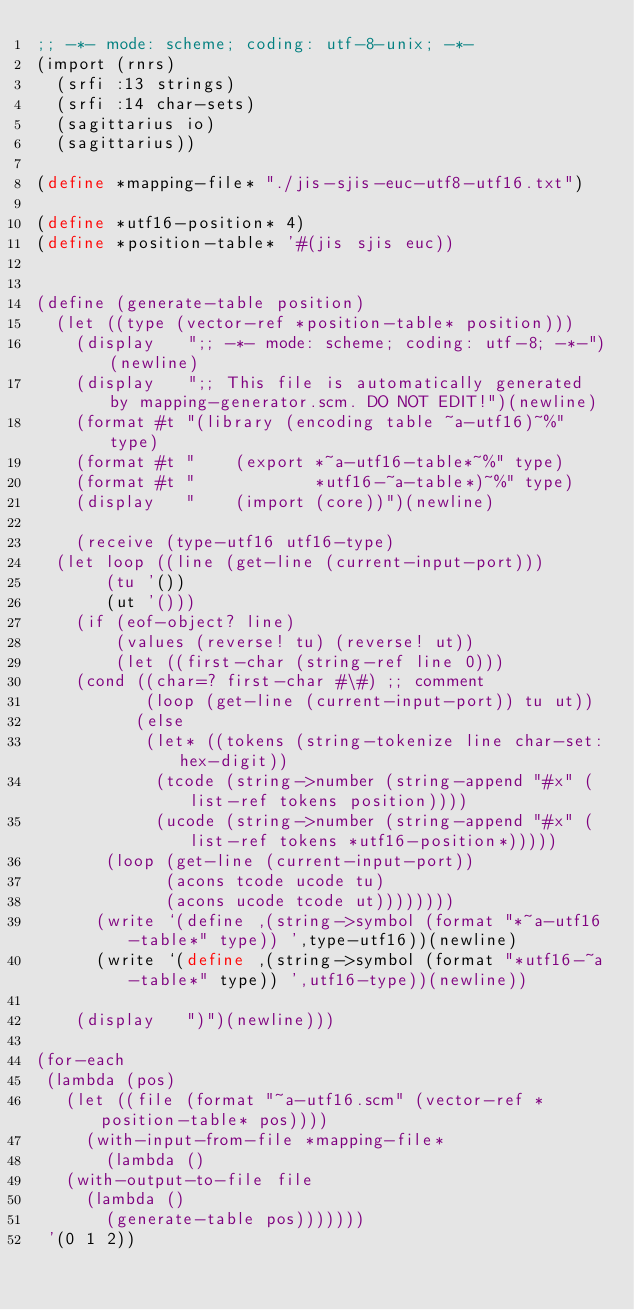Convert code to text. <code><loc_0><loc_0><loc_500><loc_500><_Scheme_>;; -*- mode: scheme; coding: utf-8-unix; -*-
(import (rnrs)
	(srfi :13 strings)
	(srfi :14 char-sets)
	(sagittarius io)
	(sagittarius))

(define *mapping-file* "./jis-sjis-euc-utf8-utf16.txt")

(define *utf16-position* 4)
(define *position-table* '#(jis sjis euc))


(define (generate-table position)
  (let ((type (vector-ref *position-table* position)))
    (display   ";; -*- mode: scheme; coding: utf-8; -*-")(newline)
    (display   ";; This file is automatically generated by mapping-generator.scm. DO NOT EDIT!")(newline)
    (format #t "(library (encoding table ~a-utf16)~%" type)
    (format #t "    (export *~a-utf16-table*~%" type)
    (format #t "            *utf16-~a-table*)~%" type)
    (display   "    (import (core))")(newline)

    (receive (type-utf16 utf16-type)
	(let loop ((line (get-line (current-input-port)))
		   (tu '())
		   (ut '()))
	  (if (eof-object? line)
	      (values (reverse! tu) (reverse! ut))
	      (let ((first-char (string-ref line 0)))
		(cond ((char=? first-char #\#) ;; comment
		       (loop (get-line (current-input-port)) tu ut))
		      (else
		       (let* ((tokens (string-tokenize line char-set:hex-digit))
			      (tcode (string->number (string-append "#x" (list-ref tokens position))))
			      (ucode (string->number (string-append "#x" (list-ref tokens *utf16-position*)))))
			 (loop (get-line (current-input-port))
			       (acons tcode ucode tu)
			       (acons ucode tcode ut))))))))
      (write `(define ,(string->symbol (format "*~a-utf16-table*" type)) ',type-utf16))(newline)
      (write `(define ,(string->symbol (format "*utf16-~a-table*" type)) ',utf16-type))(newline))

    (display   ")")(newline)))

(for-each 
 (lambda (pos) 
   (let ((file (format "~a-utf16.scm" (vector-ref *position-table* pos))))
     (with-input-from-file *mapping-file*
       (lambda ()
	 (with-output-to-file file
	   (lambda ()
	     (generate-table pos)))))))
 '(0 1 2))</code> 